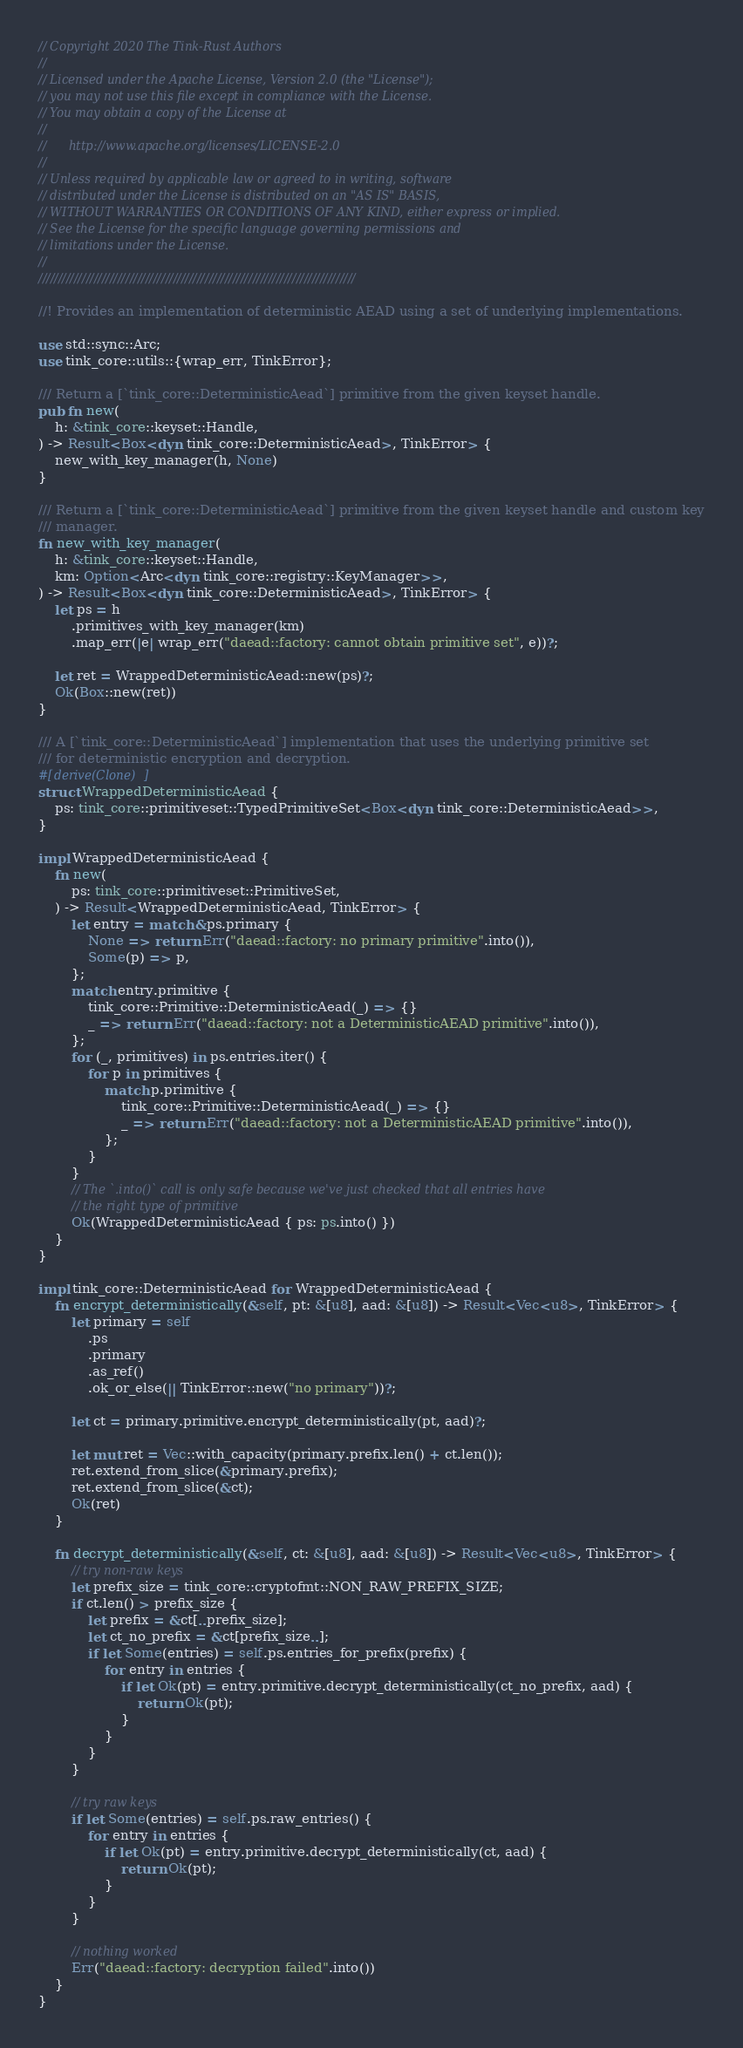Convert code to text. <code><loc_0><loc_0><loc_500><loc_500><_Rust_>// Copyright 2020 The Tink-Rust Authors
//
// Licensed under the Apache License, Version 2.0 (the "License");
// you may not use this file except in compliance with the License.
// You may obtain a copy of the License at
//
//      http://www.apache.org/licenses/LICENSE-2.0
//
// Unless required by applicable law or agreed to in writing, software
// distributed under the License is distributed on an "AS IS" BASIS,
// WITHOUT WARRANTIES OR CONDITIONS OF ANY KIND, either express or implied.
// See the License for the specific language governing permissions and
// limitations under the License.
//
////////////////////////////////////////////////////////////////////////////////

//! Provides an implementation of deterministic AEAD using a set of underlying implementations.

use std::sync::Arc;
use tink_core::utils::{wrap_err, TinkError};

/// Return a [`tink_core::DeterministicAead`] primitive from the given keyset handle.
pub fn new(
    h: &tink_core::keyset::Handle,
) -> Result<Box<dyn tink_core::DeterministicAead>, TinkError> {
    new_with_key_manager(h, None)
}

/// Return a [`tink_core::DeterministicAead`] primitive from the given keyset handle and custom key
/// manager.
fn new_with_key_manager(
    h: &tink_core::keyset::Handle,
    km: Option<Arc<dyn tink_core::registry::KeyManager>>,
) -> Result<Box<dyn tink_core::DeterministicAead>, TinkError> {
    let ps = h
        .primitives_with_key_manager(km)
        .map_err(|e| wrap_err("daead::factory: cannot obtain primitive set", e))?;

    let ret = WrappedDeterministicAead::new(ps)?;
    Ok(Box::new(ret))
}

/// A [`tink_core::DeterministicAead`] implementation that uses the underlying primitive set
/// for deterministic encryption and decryption.
#[derive(Clone)]
struct WrappedDeterministicAead {
    ps: tink_core::primitiveset::TypedPrimitiveSet<Box<dyn tink_core::DeterministicAead>>,
}

impl WrappedDeterministicAead {
    fn new(
        ps: tink_core::primitiveset::PrimitiveSet,
    ) -> Result<WrappedDeterministicAead, TinkError> {
        let entry = match &ps.primary {
            None => return Err("daead::factory: no primary primitive".into()),
            Some(p) => p,
        };
        match entry.primitive {
            tink_core::Primitive::DeterministicAead(_) => {}
            _ => return Err("daead::factory: not a DeterministicAEAD primitive".into()),
        };
        for (_, primitives) in ps.entries.iter() {
            for p in primitives {
                match p.primitive {
                    tink_core::Primitive::DeterministicAead(_) => {}
                    _ => return Err("daead::factory: not a DeterministicAEAD primitive".into()),
                };
            }
        }
        // The `.into()` call is only safe because we've just checked that all entries have
        // the right type of primitive
        Ok(WrappedDeterministicAead { ps: ps.into() })
    }
}

impl tink_core::DeterministicAead for WrappedDeterministicAead {
    fn encrypt_deterministically(&self, pt: &[u8], aad: &[u8]) -> Result<Vec<u8>, TinkError> {
        let primary = self
            .ps
            .primary
            .as_ref()
            .ok_or_else(|| TinkError::new("no primary"))?;

        let ct = primary.primitive.encrypt_deterministically(pt, aad)?;

        let mut ret = Vec::with_capacity(primary.prefix.len() + ct.len());
        ret.extend_from_slice(&primary.prefix);
        ret.extend_from_slice(&ct);
        Ok(ret)
    }

    fn decrypt_deterministically(&self, ct: &[u8], aad: &[u8]) -> Result<Vec<u8>, TinkError> {
        // try non-raw keys
        let prefix_size = tink_core::cryptofmt::NON_RAW_PREFIX_SIZE;
        if ct.len() > prefix_size {
            let prefix = &ct[..prefix_size];
            let ct_no_prefix = &ct[prefix_size..];
            if let Some(entries) = self.ps.entries_for_prefix(prefix) {
                for entry in entries {
                    if let Ok(pt) = entry.primitive.decrypt_deterministically(ct_no_prefix, aad) {
                        return Ok(pt);
                    }
                }
            }
        }

        // try raw keys
        if let Some(entries) = self.ps.raw_entries() {
            for entry in entries {
                if let Ok(pt) = entry.primitive.decrypt_deterministically(ct, aad) {
                    return Ok(pt);
                }
            }
        }

        // nothing worked
        Err("daead::factory: decryption failed".into())
    }
}
</code> 